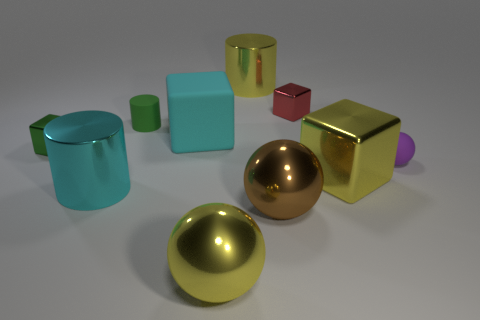Is the number of rubber cylinders that are to the left of the green cylinder less than the number of yellow objects?
Your response must be concise. Yes. What is the ball on the right side of the tiny shiny thing behind the tiny cylinder that is in front of the tiny red thing made of?
Ensure brevity in your answer.  Rubber. How many things are either purple rubber things to the right of the green matte thing or large things that are behind the small purple thing?
Provide a short and direct response. 3. What material is the other tiny object that is the same shape as the red thing?
Keep it short and to the point. Metal. How many metal things are either tiny cylinders or spheres?
Make the answer very short. 2. What shape is the cyan thing that is made of the same material as the brown sphere?
Your answer should be very brief. Cylinder. How many small green matte things are the same shape as the small purple thing?
Your answer should be compact. 0. Do the yellow metal object behind the tiny purple rubber ball and the cyan thing that is on the left side of the tiny green matte cylinder have the same shape?
Your response must be concise. Yes. What number of objects are either yellow balls or big yellow shiny objects in front of the big cyan rubber object?
Keep it short and to the point. 2. There is a tiny metal thing that is the same color as the small cylinder; what shape is it?
Keep it short and to the point. Cube. 